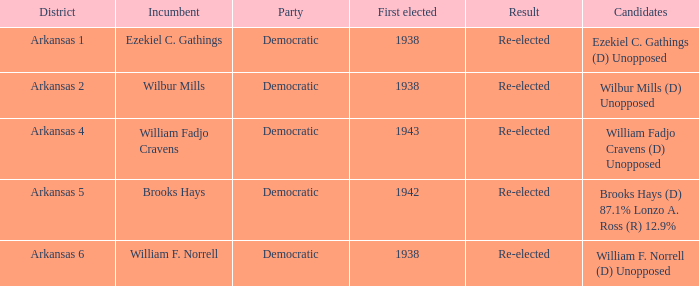What party did the incumbent from the Arkansas 5 district belong to?  Democratic. Could you help me parse every detail presented in this table? {'header': ['District', 'Incumbent', 'Party', 'First elected', 'Result', 'Candidates'], 'rows': [['Arkansas 1', 'Ezekiel C. Gathings', 'Democratic', '1938', 'Re-elected', 'Ezekiel C. Gathings (D) Unopposed'], ['Arkansas 2', 'Wilbur Mills', 'Democratic', '1938', 'Re-elected', 'Wilbur Mills (D) Unopposed'], ['Arkansas 4', 'William Fadjo Cravens', 'Democratic', '1943', 'Re-elected', 'William Fadjo Cravens (D) Unopposed'], ['Arkansas 5', 'Brooks Hays', 'Democratic', '1942', 'Re-elected', 'Brooks Hays (D) 87.1% Lonzo A. Ross (R) 12.9%'], ['Arkansas 6', 'William F. Norrell', 'Democratic', '1938', 'Re-elected', 'William F. Norrell (D) Unopposed']]} 